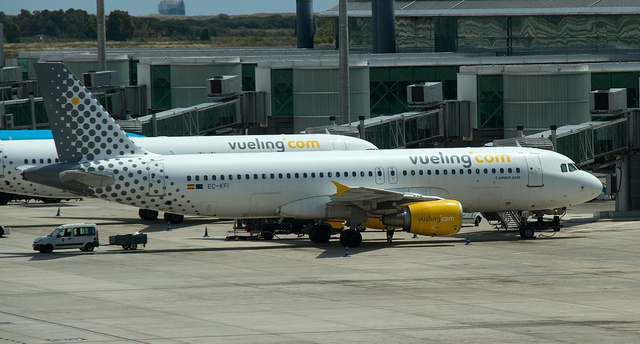Describe the objects in this image and their specific colors. I can see airplane in gray, black, white, and darkgray tones, airplane in gray, lightgray, lightblue, and darkgray tones, and truck in gray, black, purple, and darkgray tones in this image. 